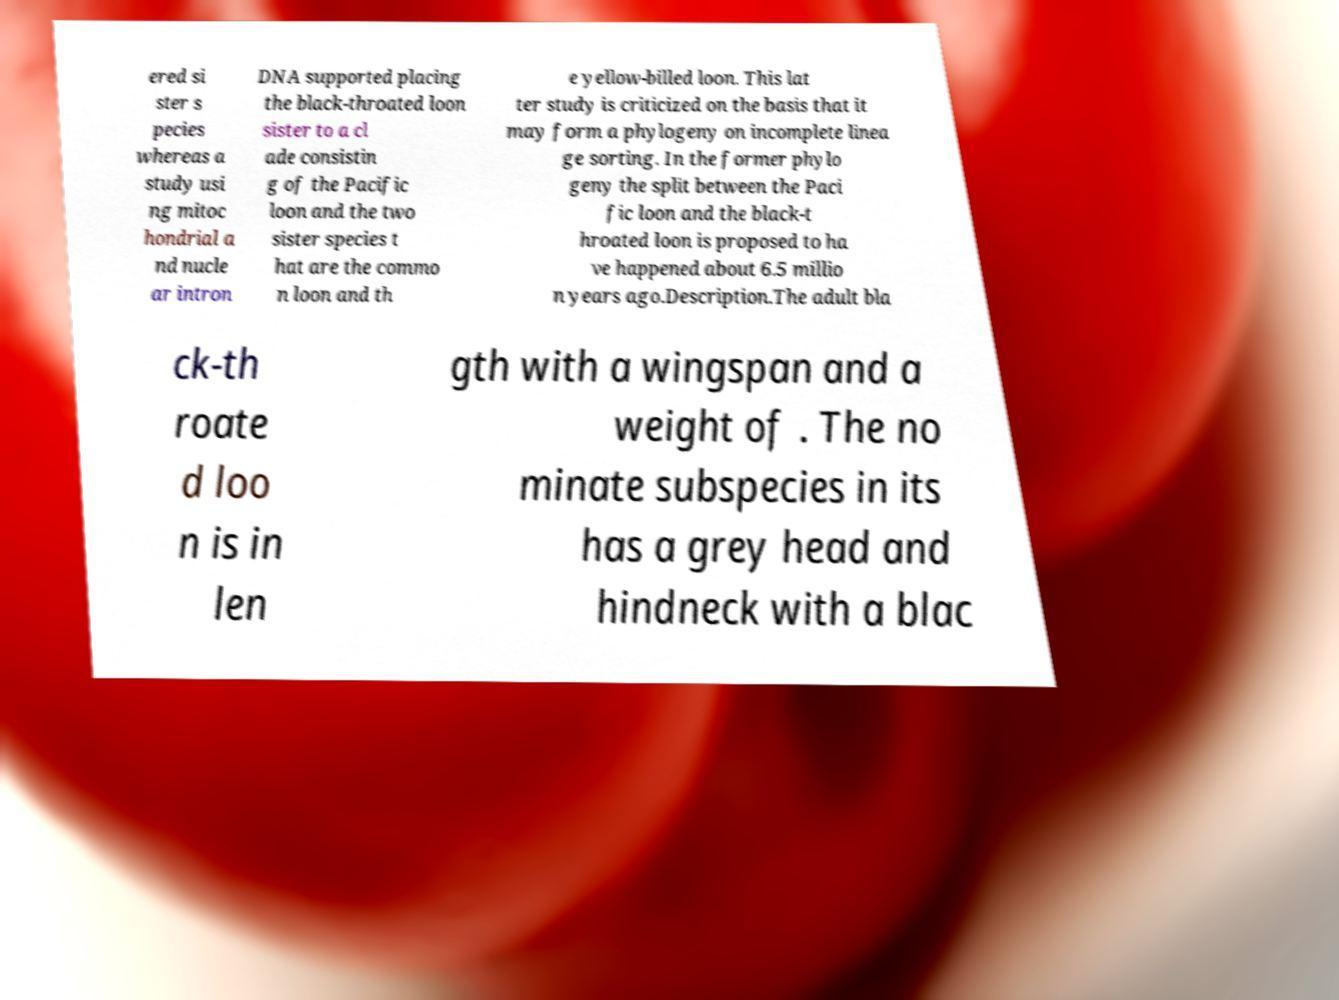Could you extract and type out the text from this image? ered si ster s pecies whereas a study usi ng mitoc hondrial a nd nucle ar intron DNA supported placing the black-throated loon sister to a cl ade consistin g of the Pacific loon and the two sister species t hat are the commo n loon and th e yellow-billed loon. This lat ter study is criticized on the basis that it may form a phylogeny on incomplete linea ge sorting. In the former phylo geny the split between the Paci fic loon and the black-t hroated loon is proposed to ha ve happened about 6.5 millio n years ago.Description.The adult bla ck-th roate d loo n is in len gth with a wingspan and a weight of . The no minate subspecies in its has a grey head and hindneck with a blac 